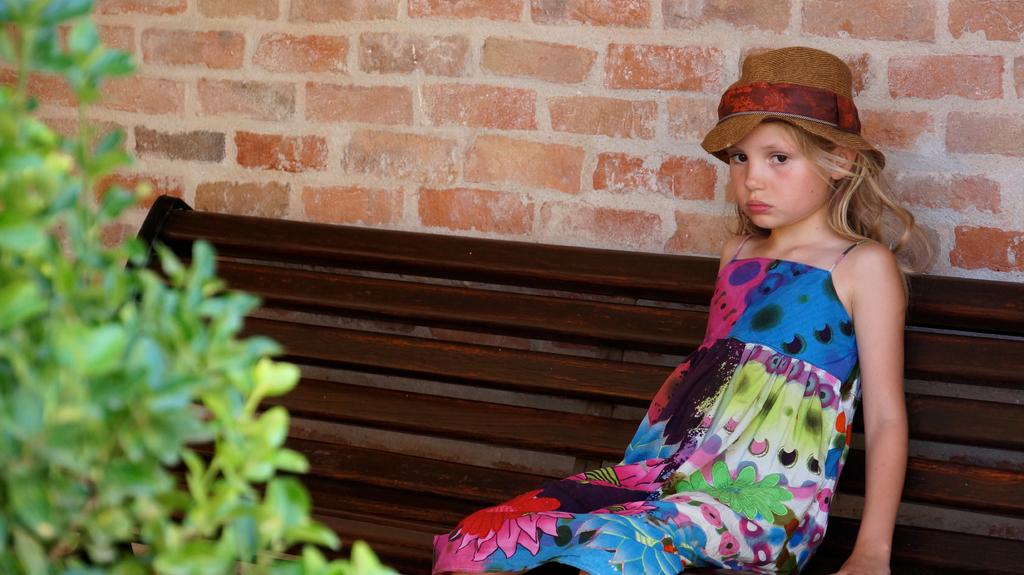Who is the main subject in the image? There is a girl in the image. What is the girl wearing on her head? The girl is wearing a hat. Where is the girl sitting in the image? The girl is sitting on a bench. What type of vegetation can be seen in the image? There is a plant in the image. What is visible in the background of the image? There is a brick wall in the background of the image. What type of nerve is visible in the image? There is no nerve visible in the image. What type of pot is present in the image? There is no pot present in the image. 